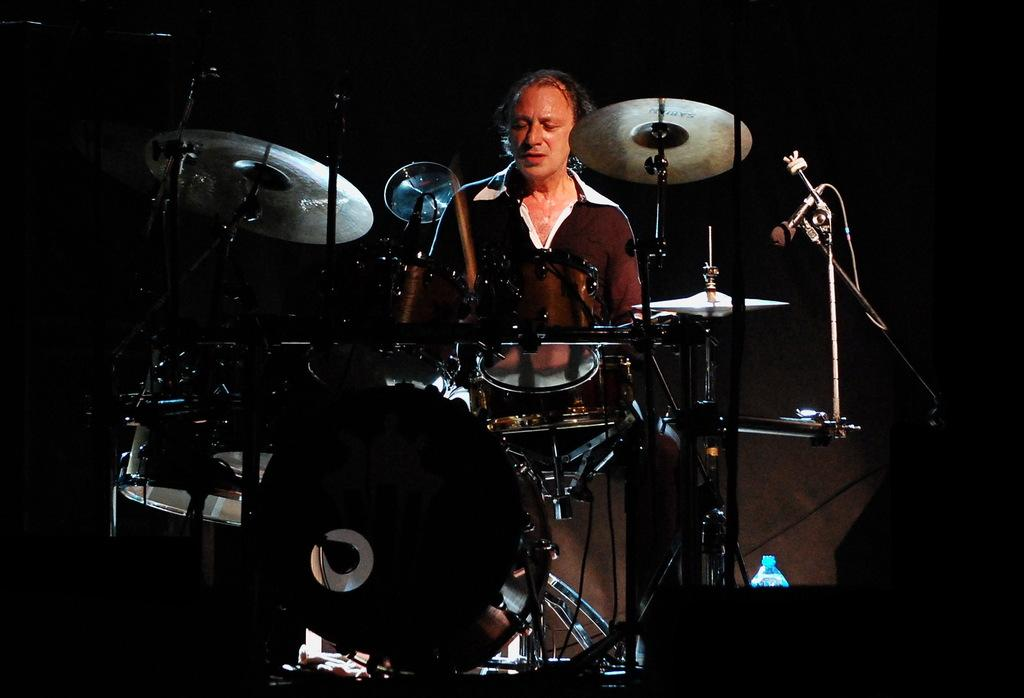Who or what is present in the image? There is a person in the image. What musical instruments can be seen in the image? There are drums and cymbals with cymbal stands in the image. What equipment is used for amplifying sound in the image? There is a microphone with a microphone stand in the image. What other object is present in the image? There is a bottle in the image. How would you describe the lighting in the image? The background of the image is dark. What type of shoes is the person wearing in the image? There is no information about shoes in the image, as the focus is on the person and the musical instruments. 